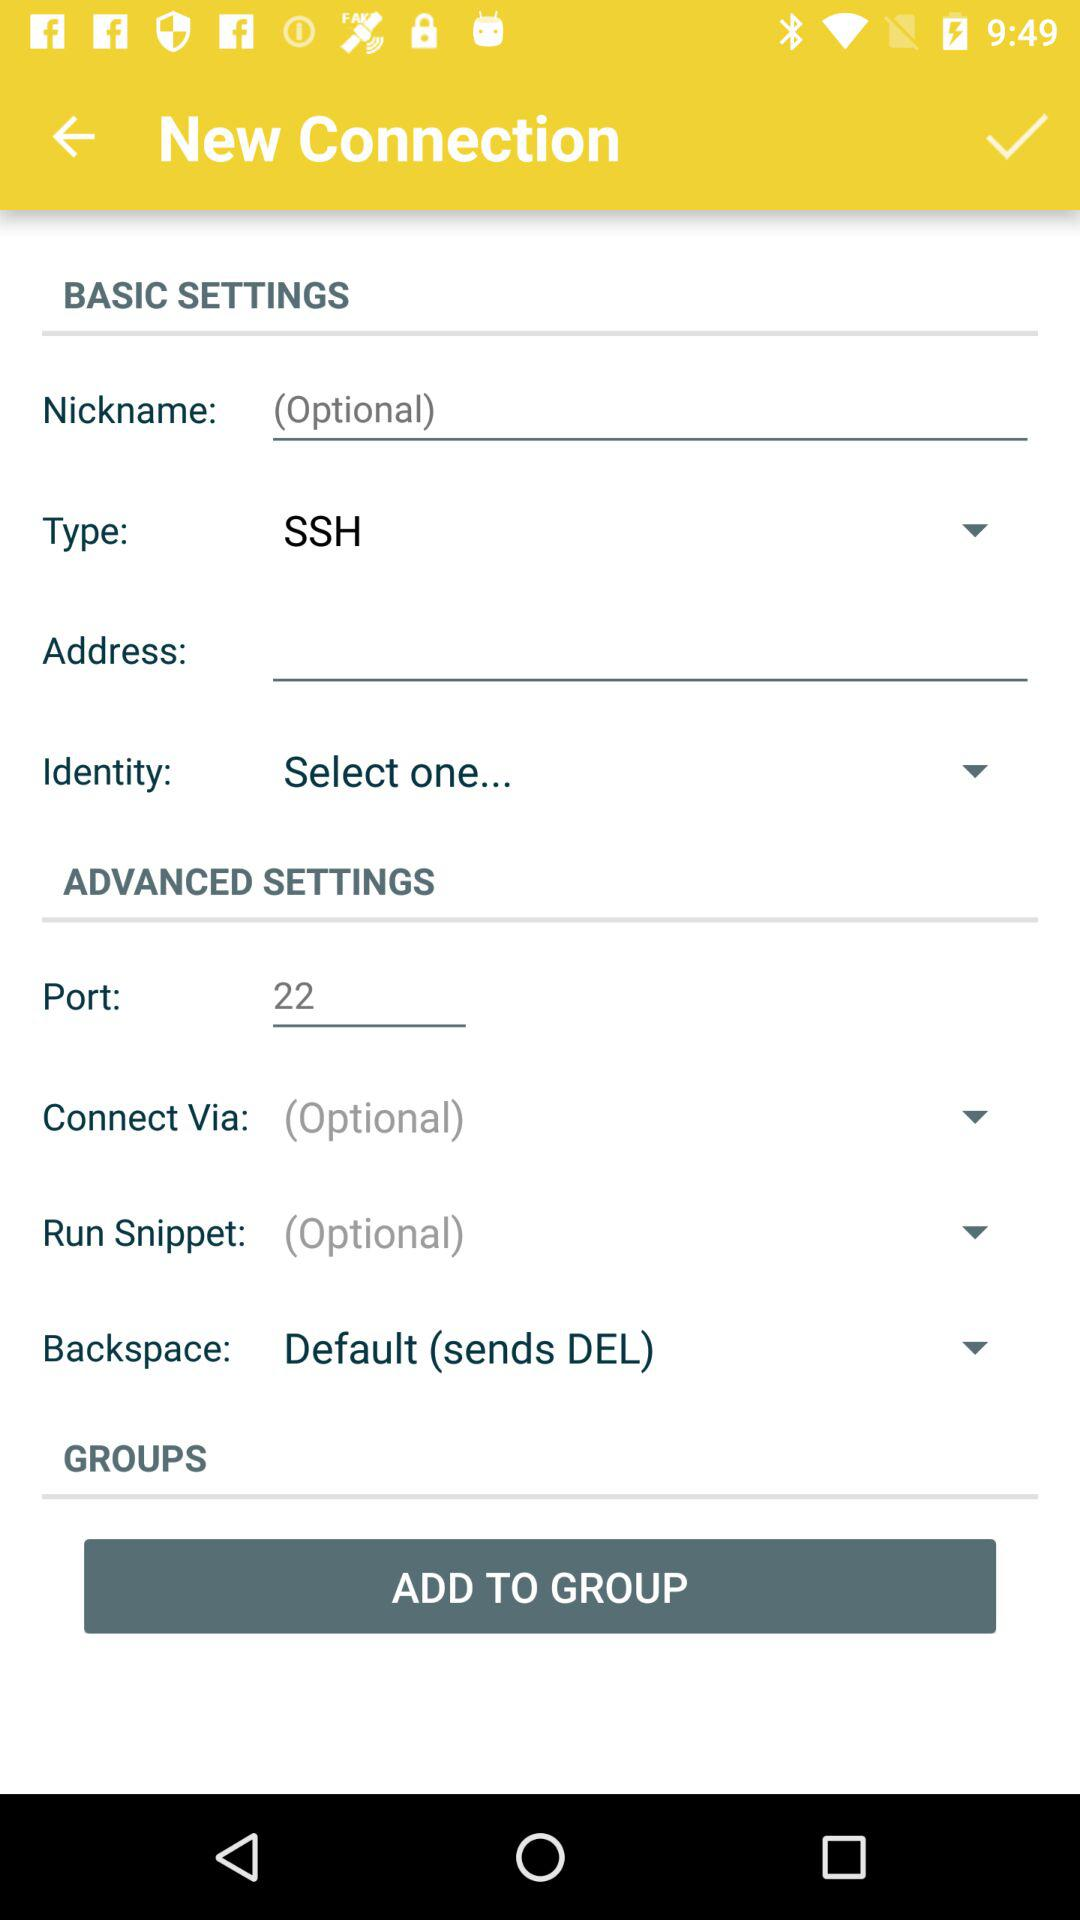What's the new connection type? The new connection type is SSH. 